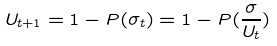<formula> <loc_0><loc_0><loc_500><loc_500>U _ { t + 1 } = 1 - P ( \sigma _ { t } ) = 1 - P ( \frac { \sigma } { U _ { t } } )</formula> 